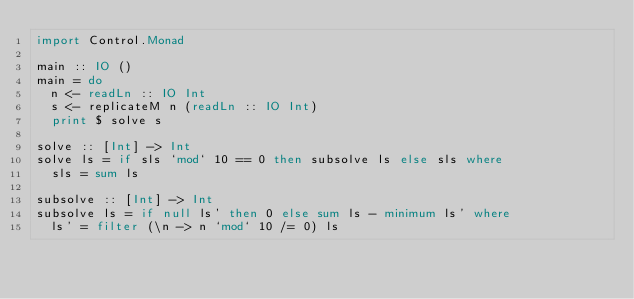<code> <loc_0><loc_0><loc_500><loc_500><_Haskell_>import Control.Monad

main :: IO ()
main = do
  n <- readLn :: IO Int
  s <- replicateM n (readLn :: IO Int)
  print $ solve s

solve :: [Int] -> Int
solve ls = if sls `mod` 10 == 0 then subsolve ls else sls where
  sls = sum ls

subsolve :: [Int] -> Int
subsolve ls = if null ls' then 0 else sum ls - minimum ls' where
  ls' = filter (\n -> n `mod` 10 /= 0) ls
</code> 